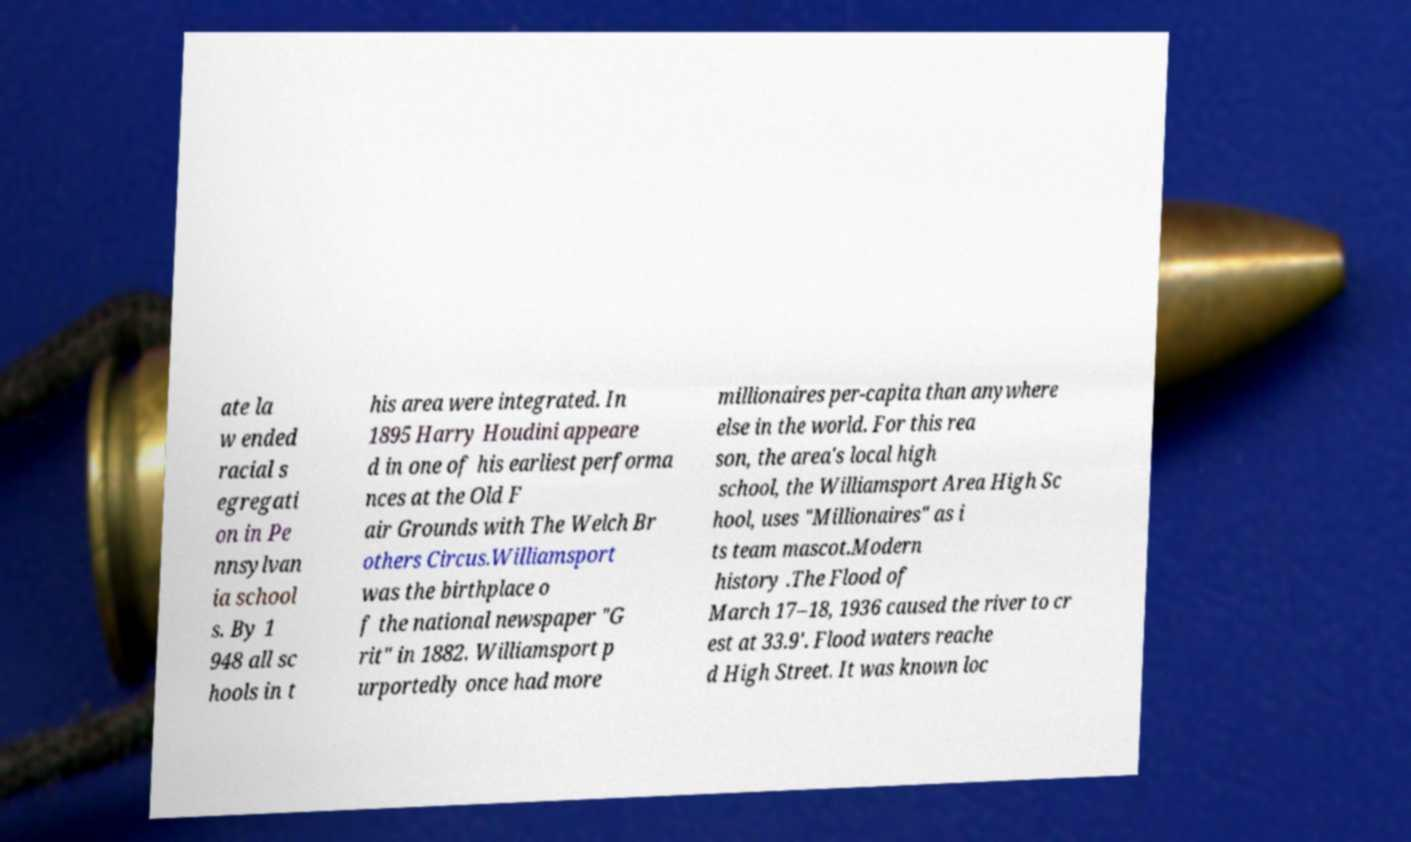Could you assist in decoding the text presented in this image and type it out clearly? ate la w ended racial s egregati on in Pe nnsylvan ia school s. By 1 948 all sc hools in t his area were integrated. In 1895 Harry Houdini appeare d in one of his earliest performa nces at the Old F air Grounds with The Welch Br others Circus.Williamsport was the birthplace o f the national newspaper "G rit" in 1882. Williamsport p urportedly once had more millionaires per-capita than anywhere else in the world. For this rea son, the area's local high school, the Williamsport Area High Sc hool, uses "Millionaires" as i ts team mascot.Modern history .The Flood of March 17–18, 1936 caused the river to cr est at 33.9'. Flood waters reache d High Street. It was known loc 